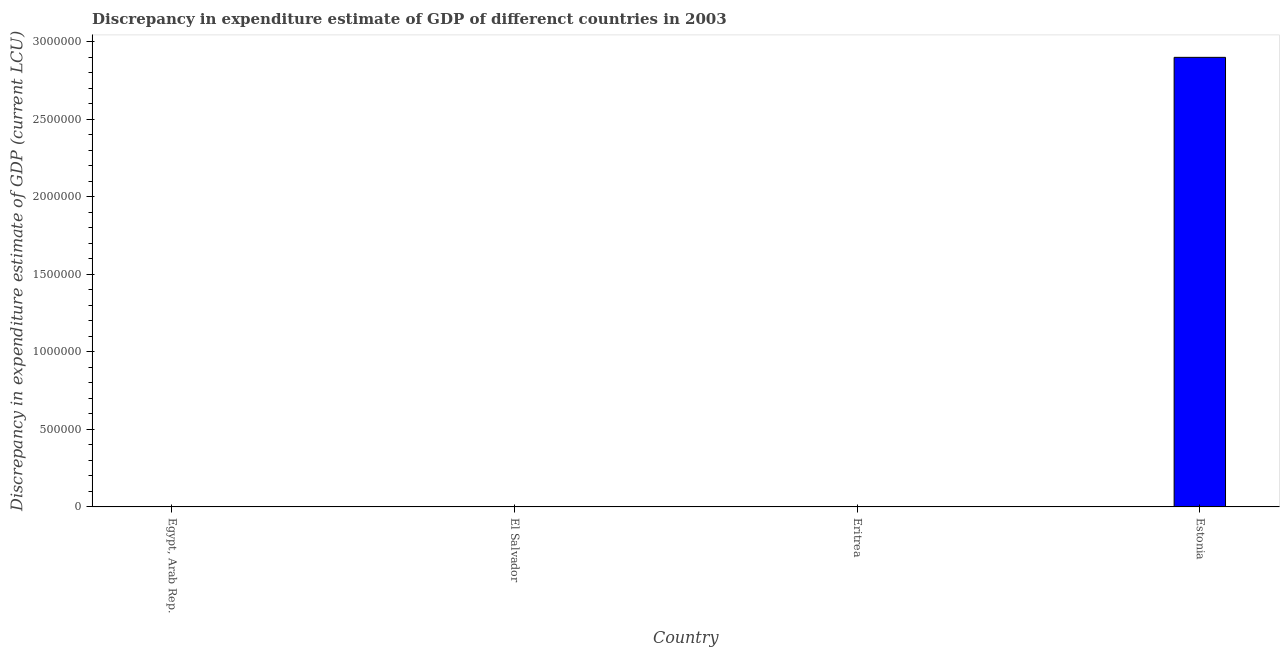What is the title of the graph?
Your answer should be very brief. Discrepancy in expenditure estimate of GDP of differenct countries in 2003. What is the label or title of the X-axis?
Your response must be concise. Country. What is the label or title of the Y-axis?
Offer a terse response. Discrepancy in expenditure estimate of GDP (current LCU). Across all countries, what is the maximum discrepancy in expenditure estimate of gdp?
Offer a terse response. 2.90e+06. In which country was the discrepancy in expenditure estimate of gdp maximum?
Make the answer very short. Estonia. What is the sum of the discrepancy in expenditure estimate of gdp?
Offer a terse response. 2.90e+06. What is the difference between the discrepancy in expenditure estimate of gdp in Eritrea and Estonia?
Offer a very short reply. -2.90e+06. What is the average discrepancy in expenditure estimate of gdp per country?
Offer a very short reply. 7.25e+05. What is the median discrepancy in expenditure estimate of gdp?
Give a very brief answer. 4.9855e-5. In how many countries, is the discrepancy in expenditure estimate of gdp greater than 2000000 LCU?
Provide a short and direct response. 1. What is the difference between the highest and the lowest discrepancy in expenditure estimate of gdp?
Make the answer very short. 2.90e+06. In how many countries, is the discrepancy in expenditure estimate of gdp greater than the average discrepancy in expenditure estimate of gdp taken over all countries?
Give a very brief answer. 1. How many bars are there?
Your answer should be compact. 2. Are all the bars in the graph horizontal?
Ensure brevity in your answer.  No. How many countries are there in the graph?
Provide a succinct answer. 4. What is the difference between two consecutive major ticks on the Y-axis?
Offer a terse response. 5.00e+05. What is the Discrepancy in expenditure estimate of GDP (current LCU) in Egypt, Arab Rep.?
Make the answer very short. 0. What is the Discrepancy in expenditure estimate of GDP (current LCU) in Eritrea?
Offer a terse response. 9.971e-5. What is the Discrepancy in expenditure estimate of GDP (current LCU) in Estonia?
Provide a short and direct response. 2.90e+06. What is the difference between the Discrepancy in expenditure estimate of GDP (current LCU) in Eritrea and Estonia?
Your answer should be very brief. -2.90e+06. What is the ratio of the Discrepancy in expenditure estimate of GDP (current LCU) in Eritrea to that in Estonia?
Provide a short and direct response. 0. 